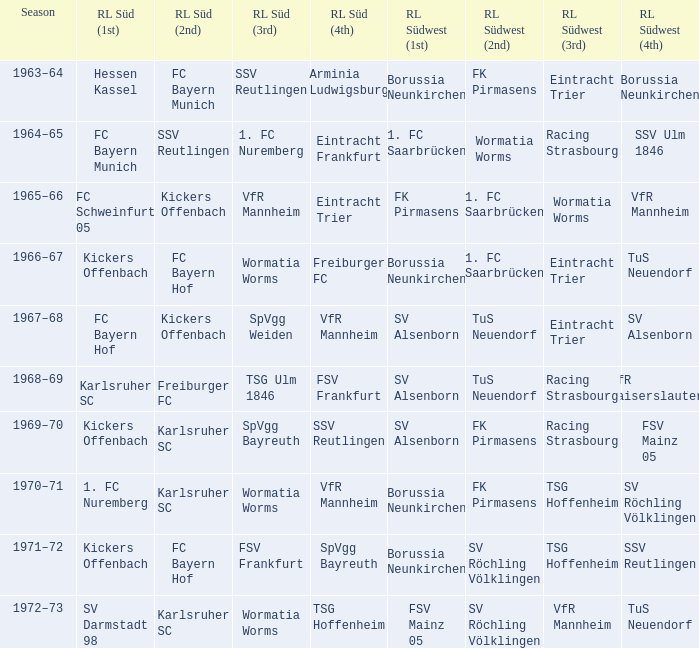What season was Freiburger FC the RL Süd (2nd) team? 1968–69. 